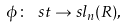<formula> <loc_0><loc_0><loc_500><loc_500>\phi \colon \ s t \to s l _ { n } ( R ) ,</formula> 